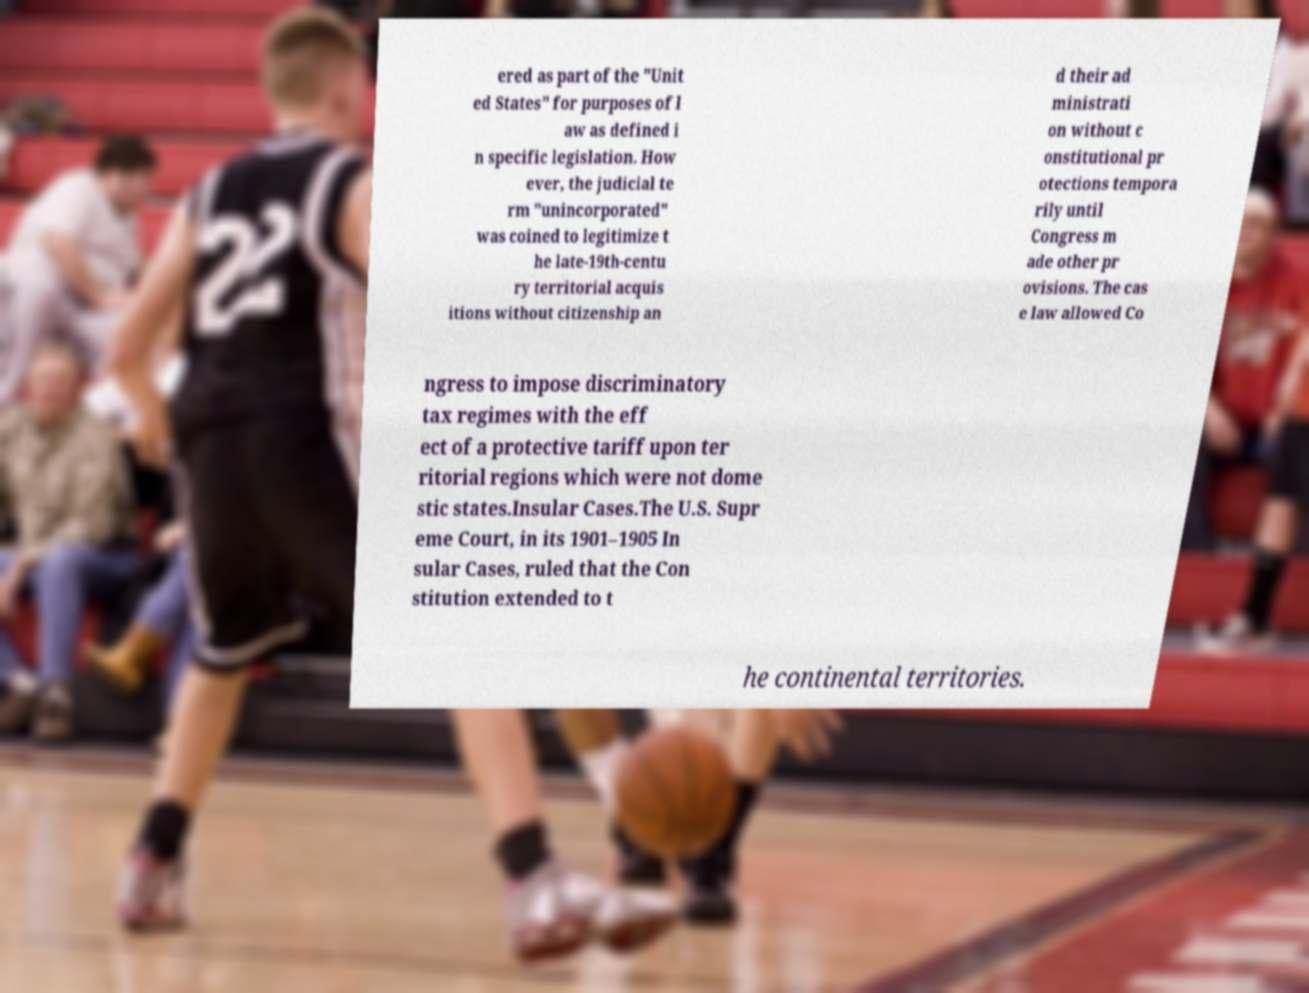Could you extract and type out the text from this image? ered as part of the "Unit ed States" for purposes of l aw as defined i n specific legislation. How ever, the judicial te rm "unincorporated" was coined to legitimize t he late-19th-centu ry territorial acquis itions without citizenship an d their ad ministrati on without c onstitutional pr otections tempora rily until Congress m ade other pr ovisions. The cas e law allowed Co ngress to impose discriminatory tax regimes with the eff ect of a protective tariff upon ter ritorial regions which were not dome stic states.Insular Cases.The U.S. Supr eme Court, in its 1901–1905 In sular Cases, ruled that the Con stitution extended to t he continental territories. 